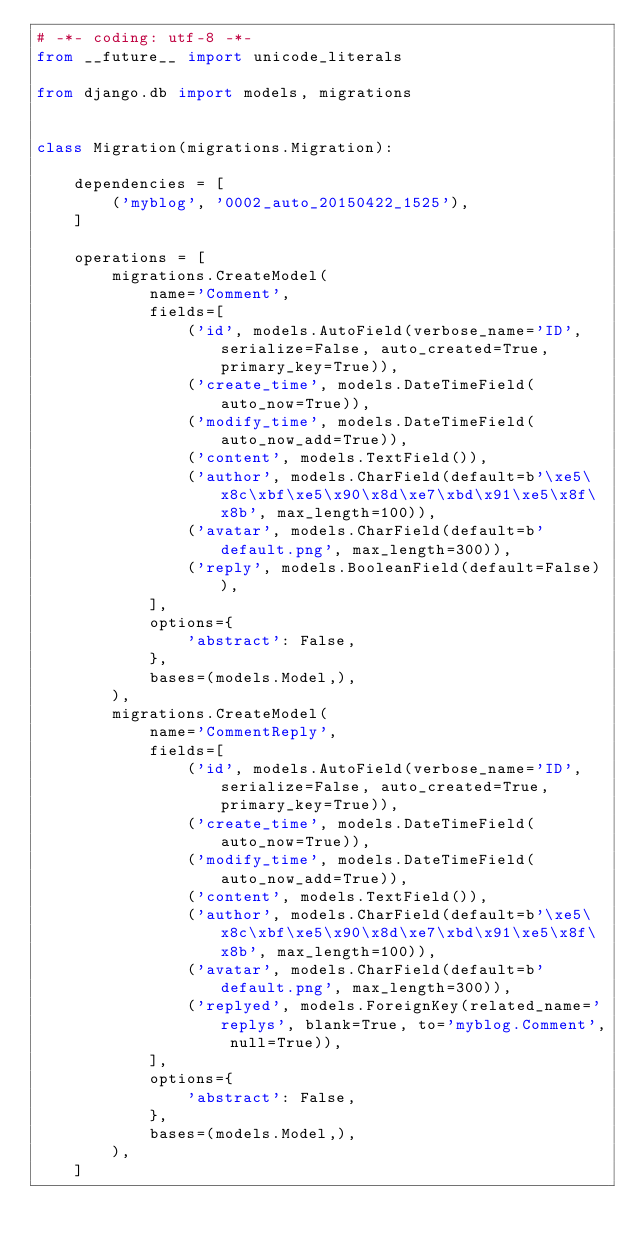<code> <loc_0><loc_0><loc_500><loc_500><_Python_># -*- coding: utf-8 -*-
from __future__ import unicode_literals

from django.db import models, migrations


class Migration(migrations.Migration):

    dependencies = [
        ('myblog', '0002_auto_20150422_1525'),
    ]

    operations = [
        migrations.CreateModel(
            name='Comment',
            fields=[
                ('id', models.AutoField(verbose_name='ID', serialize=False, auto_created=True, primary_key=True)),
                ('create_time', models.DateTimeField(auto_now=True)),
                ('modify_time', models.DateTimeField(auto_now_add=True)),
                ('content', models.TextField()),
                ('author', models.CharField(default=b'\xe5\x8c\xbf\xe5\x90\x8d\xe7\xbd\x91\xe5\x8f\x8b', max_length=100)),
                ('avatar', models.CharField(default=b'default.png', max_length=300)),
                ('reply', models.BooleanField(default=False)),
            ],
            options={
                'abstract': False,
            },
            bases=(models.Model,),
        ),
        migrations.CreateModel(
            name='CommentReply',
            fields=[
                ('id', models.AutoField(verbose_name='ID', serialize=False, auto_created=True, primary_key=True)),
                ('create_time', models.DateTimeField(auto_now=True)),
                ('modify_time', models.DateTimeField(auto_now_add=True)),
                ('content', models.TextField()),
                ('author', models.CharField(default=b'\xe5\x8c\xbf\xe5\x90\x8d\xe7\xbd\x91\xe5\x8f\x8b', max_length=100)),
                ('avatar', models.CharField(default=b'default.png', max_length=300)),
                ('replyed', models.ForeignKey(related_name='replys', blank=True, to='myblog.Comment', null=True)),
            ],
            options={
                'abstract': False,
            },
            bases=(models.Model,),
        ),
    ]
</code> 